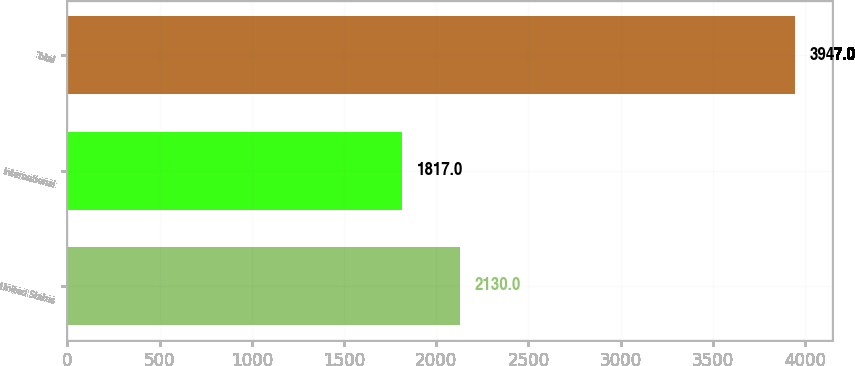Convert chart. <chart><loc_0><loc_0><loc_500><loc_500><bar_chart><fcel>United States<fcel>International<fcel>Total<nl><fcel>2130<fcel>1817<fcel>3947<nl></chart> 